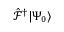<formula> <loc_0><loc_0><loc_500><loc_500>{ \hat { \mathcal { F } } ^ { \dagger } | \Psi _ { 0 } \rangle }</formula> 